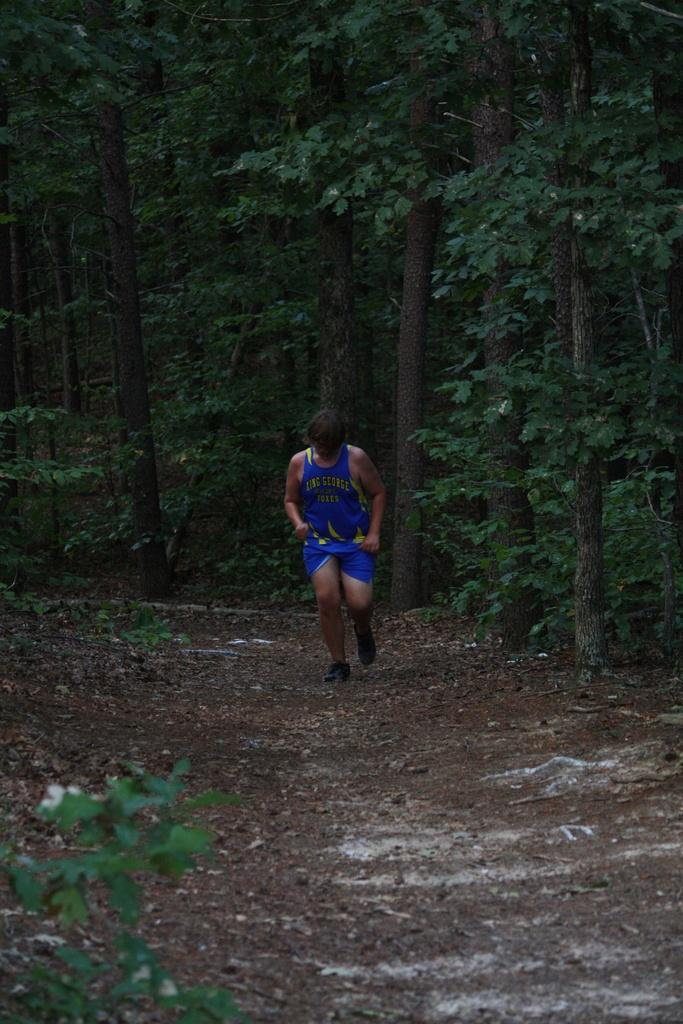What is the person in the image doing? The person is running in the image. What surface is the person running on? The person is running on the ground. What can be seen in the background of the image? There are trees in the background of the image. What type of song can be heard playing in the background of the image? There is no song or audio present in the image, as it is a still photograph. 